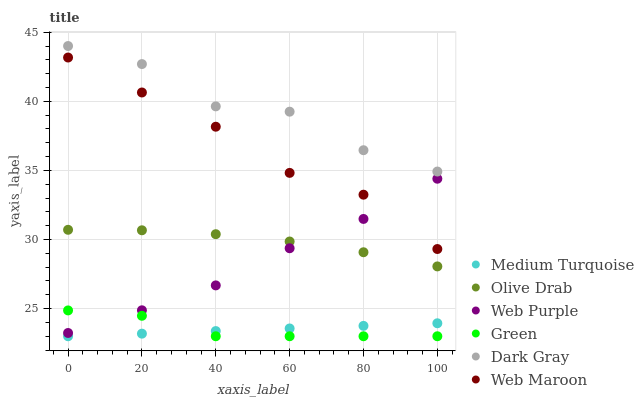Does Medium Turquoise have the minimum area under the curve?
Answer yes or no. Yes. Does Dark Gray have the maximum area under the curve?
Answer yes or no. Yes. Does Web Purple have the minimum area under the curve?
Answer yes or no. No. Does Web Purple have the maximum area under the curve?
Answer yes or no. No. Is Medium Turquoise the smoothest?
Answer yes or no. Yes. Is Dark Gray the roughest?
Answer yes or no. Yes. Is Web Purple the smoothest?
Answer yes or no. No. Is Web Purple the roughest?
Answer yes or no. No. Does Green have the lowest value?
Answer yes or no. Yes. Does Web Purple have the lowest value?
Answer yes or no. No. Does Dark Gray have the highest value?
Answer yes or no. Yes. Does Web Purple have the highest value?
Answer yes or no. No. Is Green less than Web Maroon?
Answer yes or no. Yes. Is Dark Gray greater than Web Maroon?
Answer yes or no. Yes. Does Web Purple intersect Web Maroon?
Answer yes or no. Yes. Is Web Purple less than Web Maroon?
Answer yes or no. No. Is Web Purple greater than Web Maroon?
Answer yes or no. No. Does Green intersect Web Maroon?
Answer yes or no. No. 